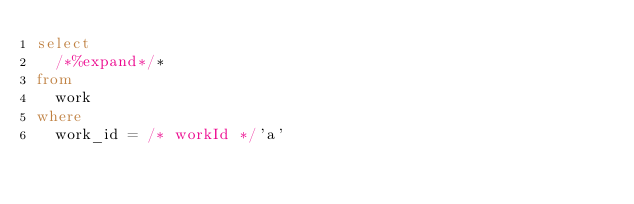Convert code to text. <code><loc_0><loc_0><loc_500><loc_500><_SQL_>select
  /*%expand*/*
from
  work
where
  work_id = /* workId */'a'
</code> 